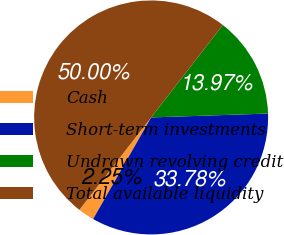<chart> <loc_0><loc_0><loc_500><loc_500><pie_chart><fcel>Cash<fcel>Short-term investments<fcel>Undrawn revolving credit<fcel>Total available liquidity<nl><fcel>2.25%<fcel>33.78%<fcel>13.97%<fcel>50.0%<nl></chart> 